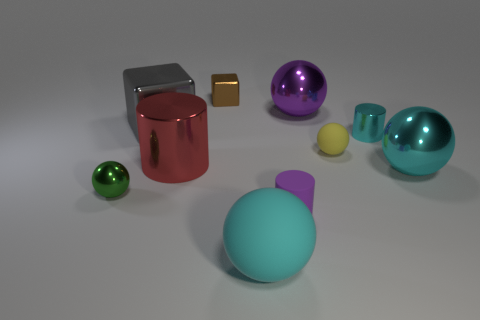What is the color of the big metal sphere that is left of the small rubber object that is to the right of the small cylinder that is to the left of the big purple object?
Make the answer very short. Purple. There is a thing to the left of the large metallic thing that is to the left of the red thing; what shape is it?
Keep it short and to the point. Sphere. Are there more metal objects that are on the left side of the large shiny block than small blue rubber objects?
Provide a succinct answer. Yes. There is a rubber thing that is in front of the small purple cylinder; does it have the same shape as the tiny yellow thing?
Your answer should be compact. Yes. Are there any other big things that have the same shape as the purple metallic thing?
Offer a very short reply. Yes. How many objects are metallic spheres in front of the purple shiny ball or spheres?
Provide a short and direct response. 5. Are there more tiny things than purple things?
Your answer should be very brief. Yes. Are there any things that have the same size as the gray metal block?
Provide a short and direct response. Yes. What number of things are either cyan things that are on the right side of the big cyan rubber thing or big things that are behind the green metallic thing?
Make the answer very short. 5. There is a tiny cylinder that is behind the large metallic ball in front of the tiny cyan object; what color is it?
Keep it short and to the point. Cyan. 